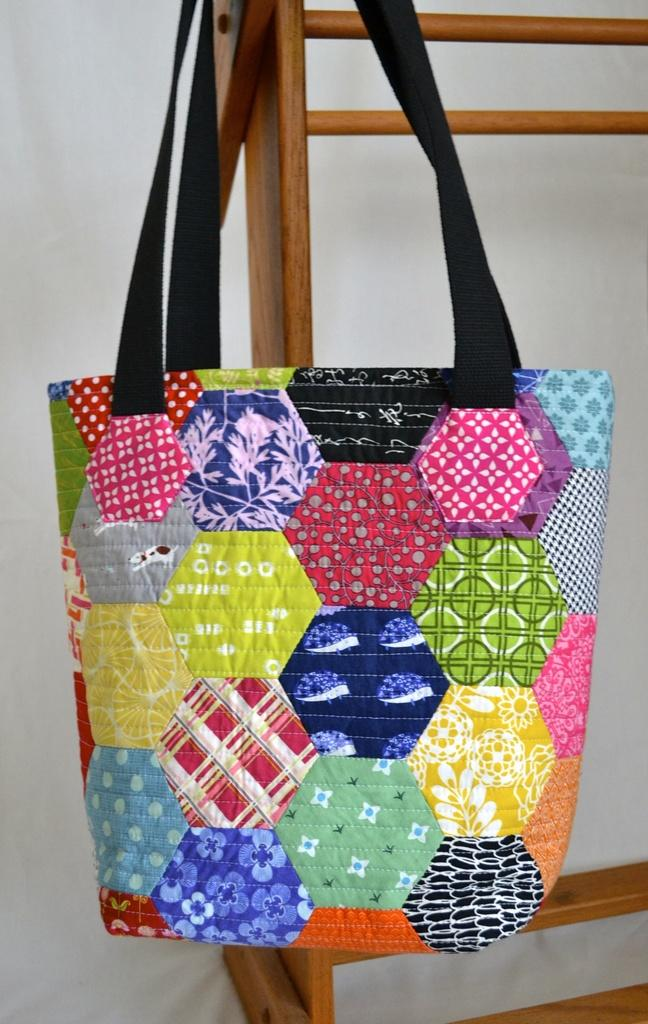What type of accessory is visible in the image? There is a hand purse in the image. Can you describe the appearance of the hand purse? The hand purse has different colors on it. Can you see any ships or yaks in the image? No, there are no ships or yaks present in the image. 